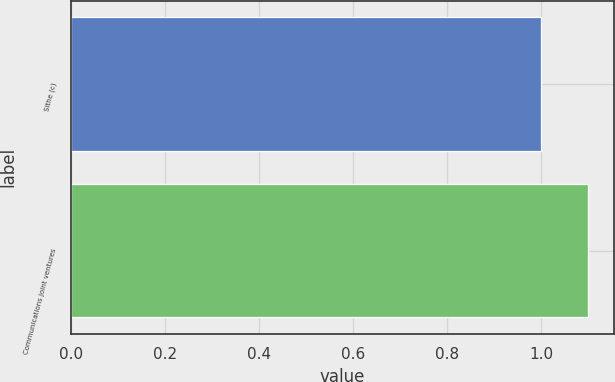Convert chart to OTSL. <chart><loc_0><loc_0><loc_500><loc_500><bar_chart><fcel>Sithe (c)<fcel>Communications joint ventures<nl><fcel>1<fcel>1.1<nl></chart> 